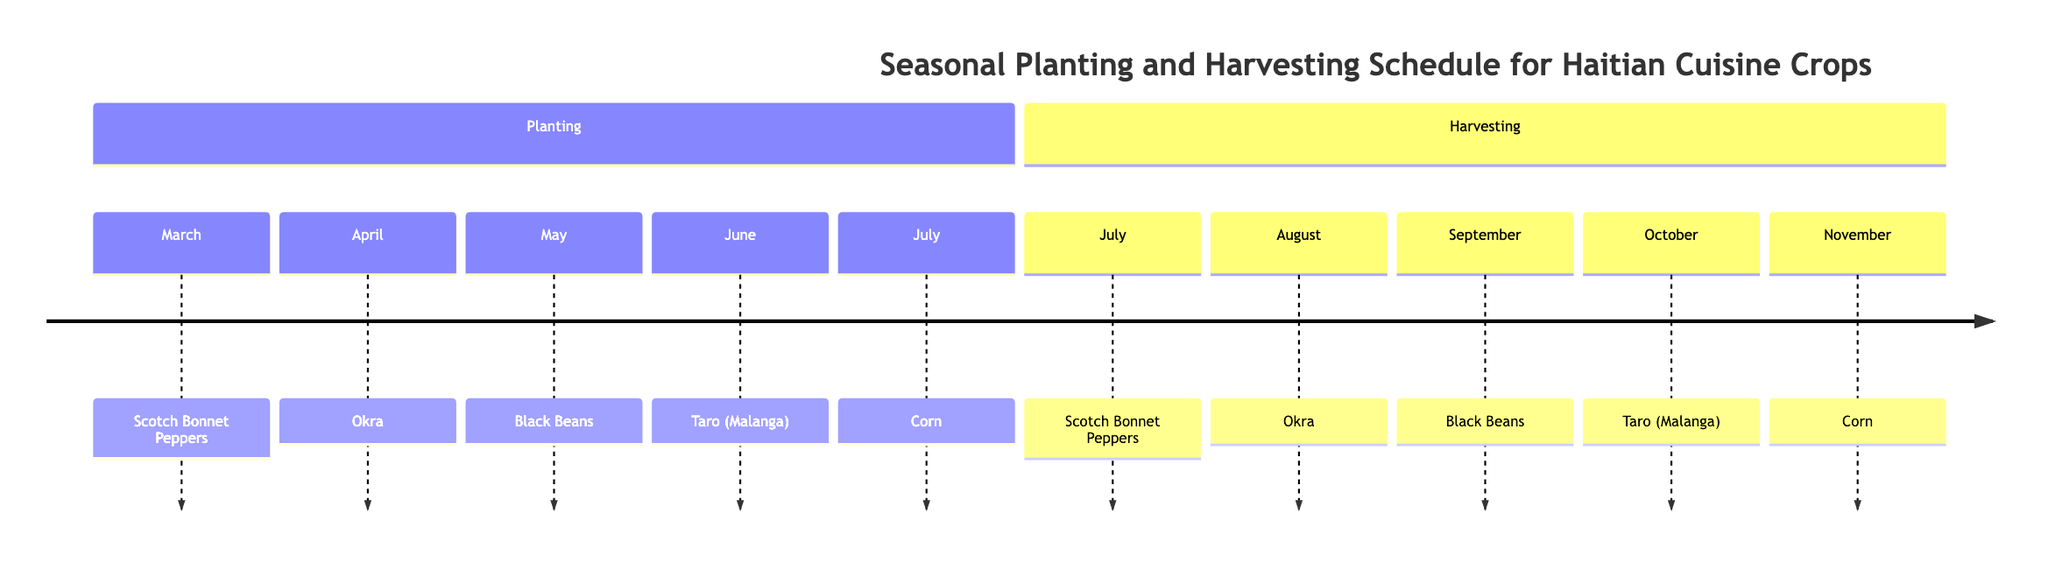What crop is planted in April? According to the timeline, April corresponds to the planting of Okra.
Answer: Okra When is the harvesting season for Black Beans? The timeline shows that Black Beans are harvested in September.
Answer: September How many crops are planted before July? By reviewing the planting section, there are four crops (Scotch Bonnet Peppers, Okra, Black Beans, and Taro (Malanga)) planted before July.
Answer: 4 What is the last crop harvested in the timeline? The timeline indicates that Corn is the last crop to be harvested in November.
Answer: Corn Which crop has planting and harvesting seasons in the same month? The timeline shows that Scotch Bonnet Peppers are planted in March and harvested in July, but no crop has both planting and harvesting seasons in the same month.
Answer: None During which month is Taro (Malanga) harvested? The timeline indicates that Taro (Malanga) is harvested in October.
Answer: October What season follows the planting of Corn? The timeline shows that Corn is planted in July, and the next season following that is harvesting, which occurs in November.
Answer: November How long is the growing season for Okra? Okra is planted in April and harvested in August, providing a growing season of approximately four months.
Answer: 4 months 